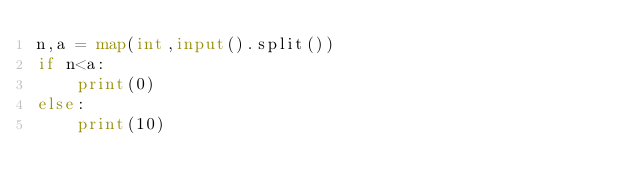<code> <loc_0><loc_0><loc_500><loc_500><_Python_>n,a = map(int,input().split())
if n<a:
    print(0)
else:
    print(10)</code> 